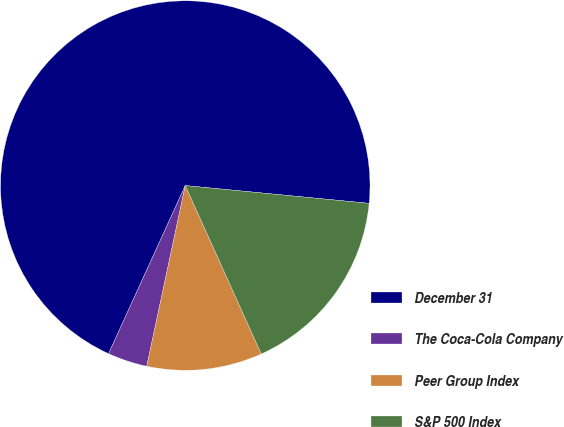Convert chart to OTSL. <chart><loc_0><loc_0><loc_500><loc_500><pie_chart><fcel>December 31<fcel>The Coca-Cola Company<fcel>Peer Group Index<fcel>S&P 500 Index<nl><fcel>69.73%<fcel>3.47%<fcel>10.09%<fcel>16.72%<nl></chart> 